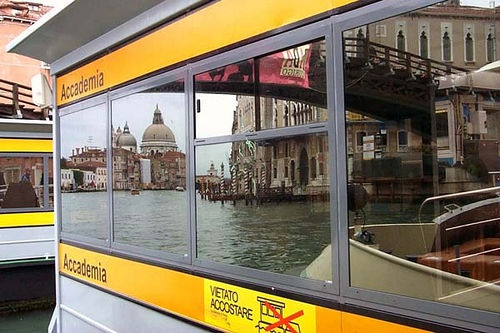Describe the objects in this image and their specific colors. I can see boat in salmon, black, lightgray, gray, and tan tones and boat in salmon, gray, maroon, and darkgray tones in this image. 